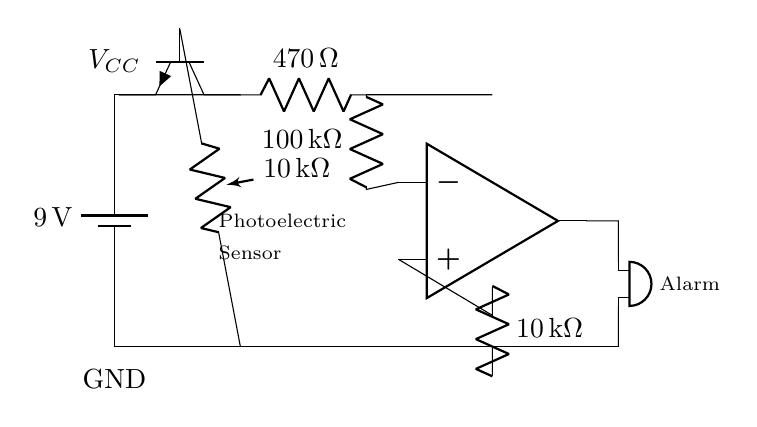What is the power supply voltage? The power supply voltage is indicated by the battery symbol at the top left of the diagram, marked as 9 volts.
Answer: 9 volts What component is used to detect smoke? The component labeled as 'Photoelectric Sensor' is identified in the diagram, which is responsible for smoke detection.
Answer: Photoelectric Sensor How many resistors are in the circuit? There are three resistors shown in the circuit: one of 470 ohms, one of 10k ohms, and one of 100k ohms.
Answer: Three What is the function of the operational amplifier in this circuit? The operational amplifier, designated as 'OA', is responsible for comparing the voltage input from the photoelectric sensor and triggering the output to activate the alarm.
Answer: Comparator What is the output device in this circuit? The component that produces an audible alert is labeled as 'Buzzer', which serves as the alarm output in the circuit.
Answer: Buzzer What determines if the alarm will sound? The alarm will sound when the voltage from the photoelectric sensor exceeds a certain threshold, as processed by the operational amplifier, which outputs to the buzzer.
Answer: Voltage threshold What is the purpose of the 10k ohm resistor connected to the photoelectric sensor? The 10k ohm resistor acts as a pull-down resistor for the base of the transistor, ensuring it can turn off completely when no voltage is applied from the photoelectric sensor, stabilizing the circuit's operation.
Answer: Stabilization 